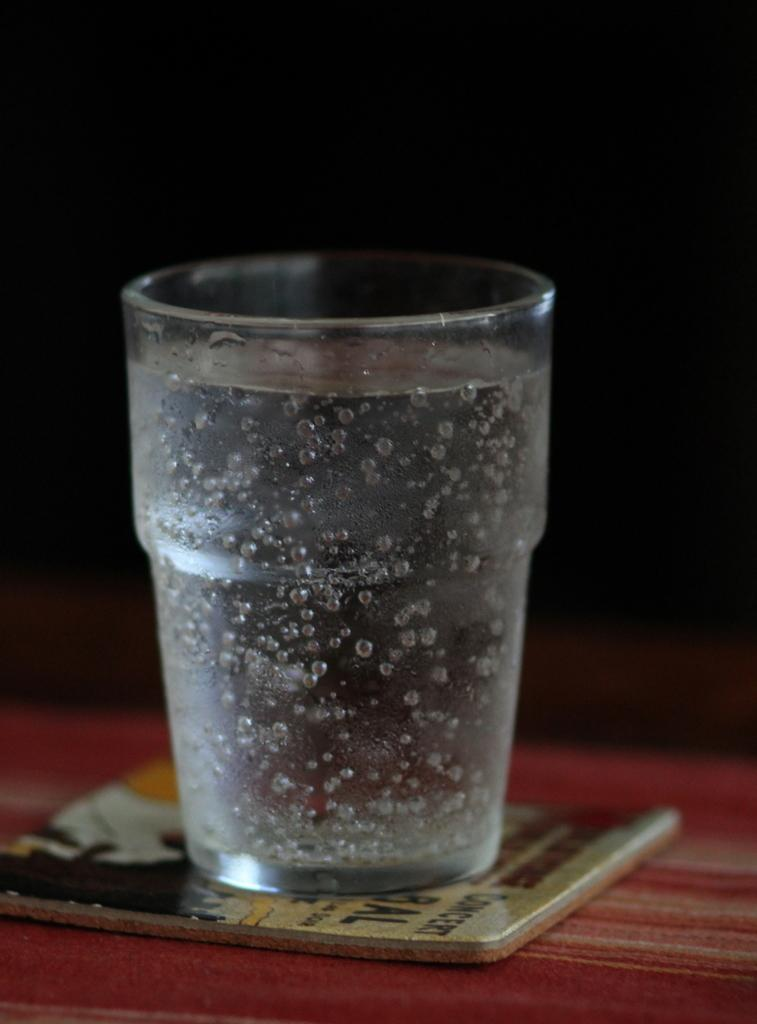What is the main object visible in the image? There is a glass in the image. Can you describe the surface on which the object is placed? The object is placed on a red color surface in the image. How would you describe the overall lighting or color scheme of the image? The background of the image is dark. What type of blood is visible on the page in the image? There is no blood or page present in the image; it only features a glass on a red surface with a dark background. 